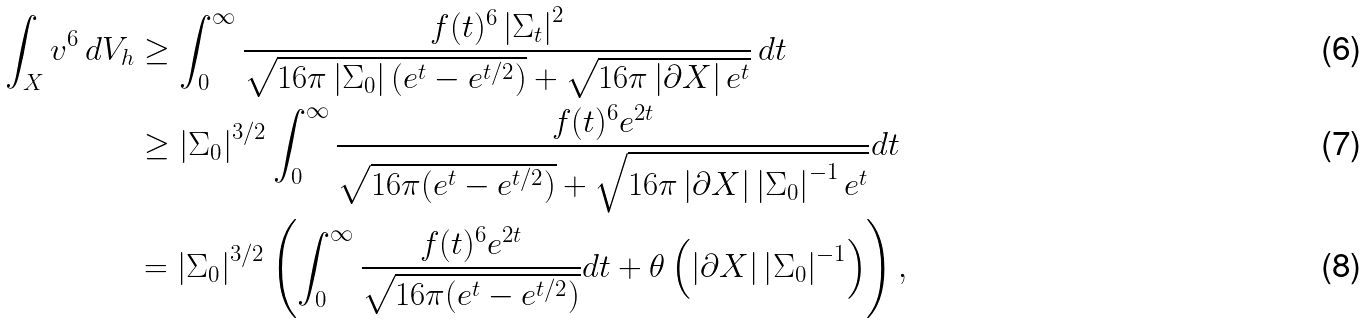Convert formula to latex. <formula><loc_0><loc_0><loc_500><loc_500>\int _ { X } v ^ { 6 } \, d V _ { h } & \geq \int _ { 0 } ^ { \infty } \frac { f ( t ) ^ { 6 } \left | \Sigma _ { t } \right | ^ { 2 } } { \sqrt { 1 6 \pi \left | \Sigma _ { 0 } \right | ( e ^ { t } - e ^ { t / 2 } ) } + \sqrt { 1 6 \pi \left | \partial X \right | e ^ { t } } } \, d t \\ & \geq \left | \Sigma _ { 0 } \right | ^ { 3 / 2 } \int _ { 0 } ^ { \infty } \frac { f ( t ) ^ { 6 } e ^ { 2 t } } { \sqrt { 1 6 \pi ( e ^ { t } - e ^ { t / 2 } ) } + \sqrt { 1 6 \pi \left | \partial X \right | \left | \Sigma _ { 0 } \right | ^ { - 1 } e ^ { t } } } d t \\ & = \left | \Sigma _ { 0 } \right | ^ { 3 / 2 } \left ( \int _ { 0 } ^ { \infty } \frac { f ( t ) ^ { 6 } e ^ { 2 t } } { \sqrt { 1 6 \pi ( e ^ { t } - e ^ { t / 2 } ) } } d t + { \theta } \left ( \left | \partial X \right | \left | \Sigma _ { 0 } \right | ^ { - 1 } \right ) \right ) ,</formula> 